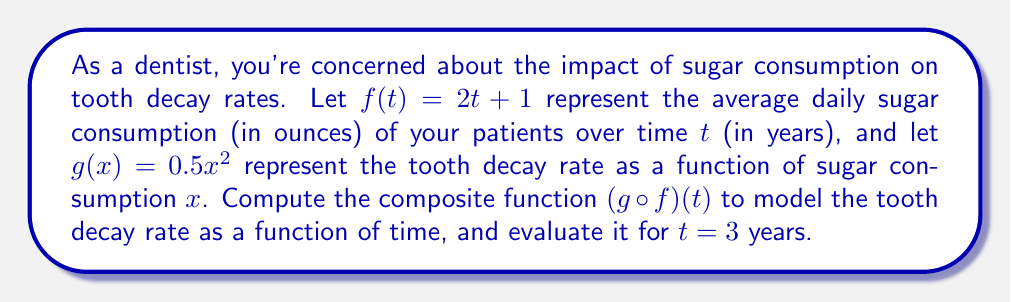Show me your answer to this math problem. To solve this problem, we need to follow these steps:

1) First, let's recall the definition of a composite function. For $(g \circ f)(t)$, we replace every $x$ in $g(x)$ with $f(t)$.

2) We're given:
   $f(t) = 2t + 1$
   $g(x) = 0.5x^2$

3) To find $(g \circ f)(t)$, we substitute $f(t)$ for $x$ in $g(x)$:
   
   $(g \circ f)(t) = g(f(t)) = 0.5(f(t))^2$

4) Now, we replace $f(t)$ with its actual expression:
   
   $(g \circ f)(t) = 0.5(2t + 1)^2$

5) Let's expand this:
   
   $(g \circ f)(t) = 0.5(4t^2 + 4t + 1)$
   
   $(g \circ f)(t) = 2t^2 + 2t + 0.5$

6) This is our final expression for the composite function. Now, we need to evaluate it for $t=3$:
   
   $(g \circ f)(3) = 2(3)^2 + 2(3) + 0.5$
   
   $(g \circ f)(3) = 2(9) + 6 + 0.5$
   
   $(g \circ f)(3) = 18 + 6 + 0.5 = 24.5$

Therefore, after 3 years, the tooth decay rate would be 24.5 units (the units would depend on how the original tooth decay rate was measured).
Answer: The composite function is $(g \circ f)(t) = 2t^2 + 2t + 0.5$, and $(g \circ f)(3) = 24.5$. 